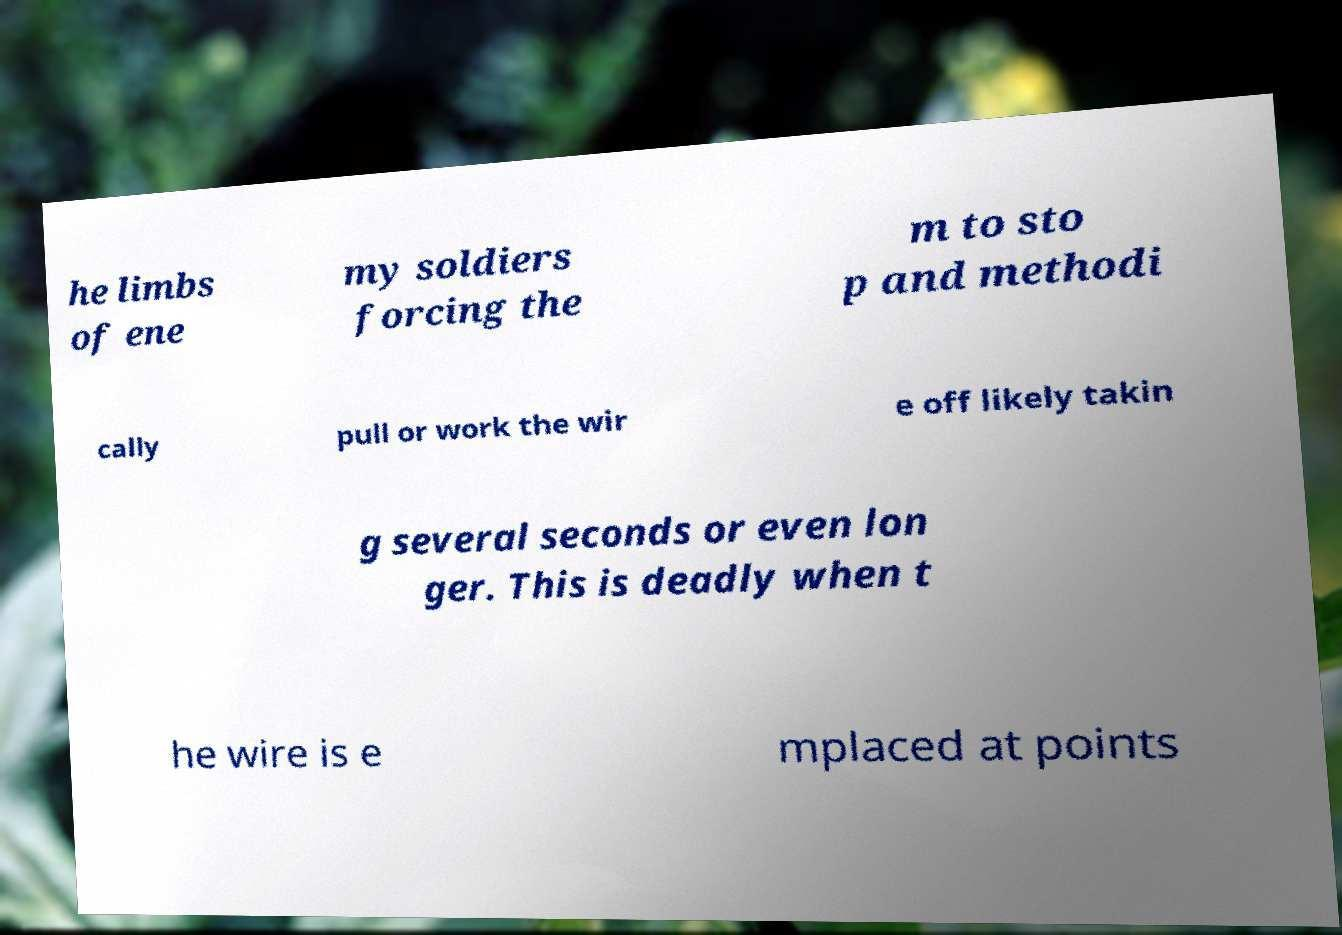What messages or text are displayed in this image? I need them in a readable, typed format. he limbs of ene my soldiers forcing the m to sto p and methodi cally pull or work the wir e off likely takin g several seconds or even lon ger. This is deadly when t he wire is e mplaced at points 